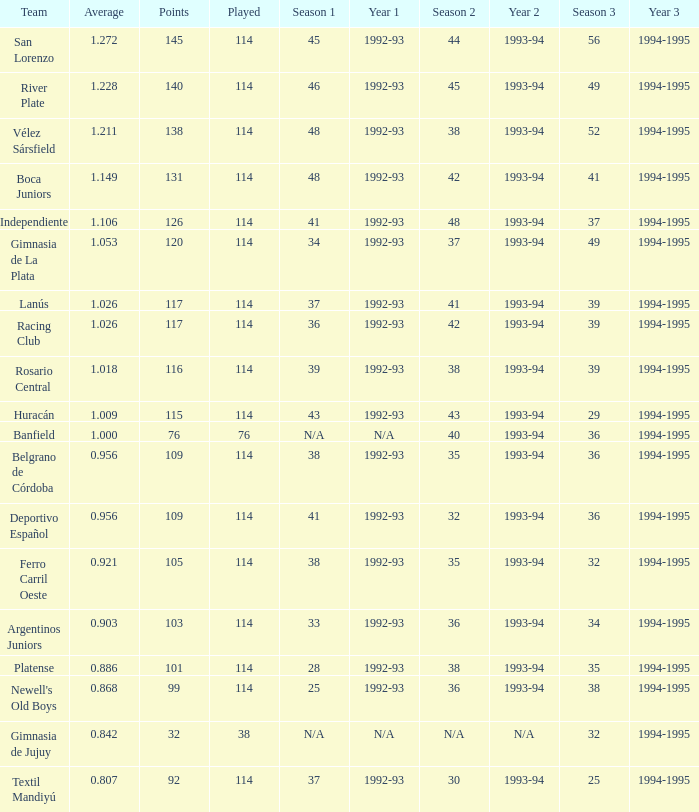Name the most played 114.0. 